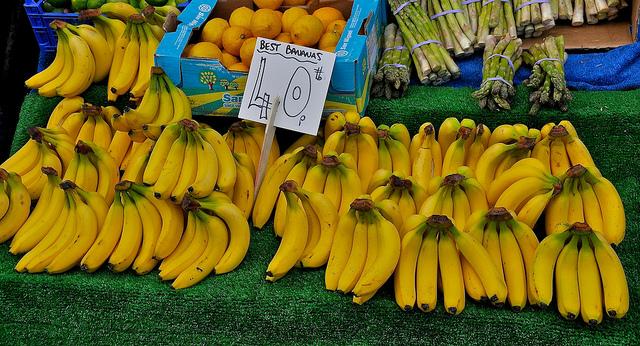How much are the bananas?
Short answer required. 40p. How many bunches of bananas are in the picture?
Quick response, please. 33. What is behind the bananas?
Be succinct. Asparagus. How much is each bunch of bananas?
Concise answer only. 40 p. Are these bananas ready to eat?
Give a very brief answer. Yes. What are the vegetables for?
Short answer required. Eating. What are the bananas being displayed in?
Write a very short answer. Shelf. How many bananas are there?
Be succinct. 56. How much do the bananas cost?
Keep it brief. 40 cents. How many bananas are in each bunch?
Keep it brief. 4. How many different type of produce are shown?
Concise answer only. 3. 